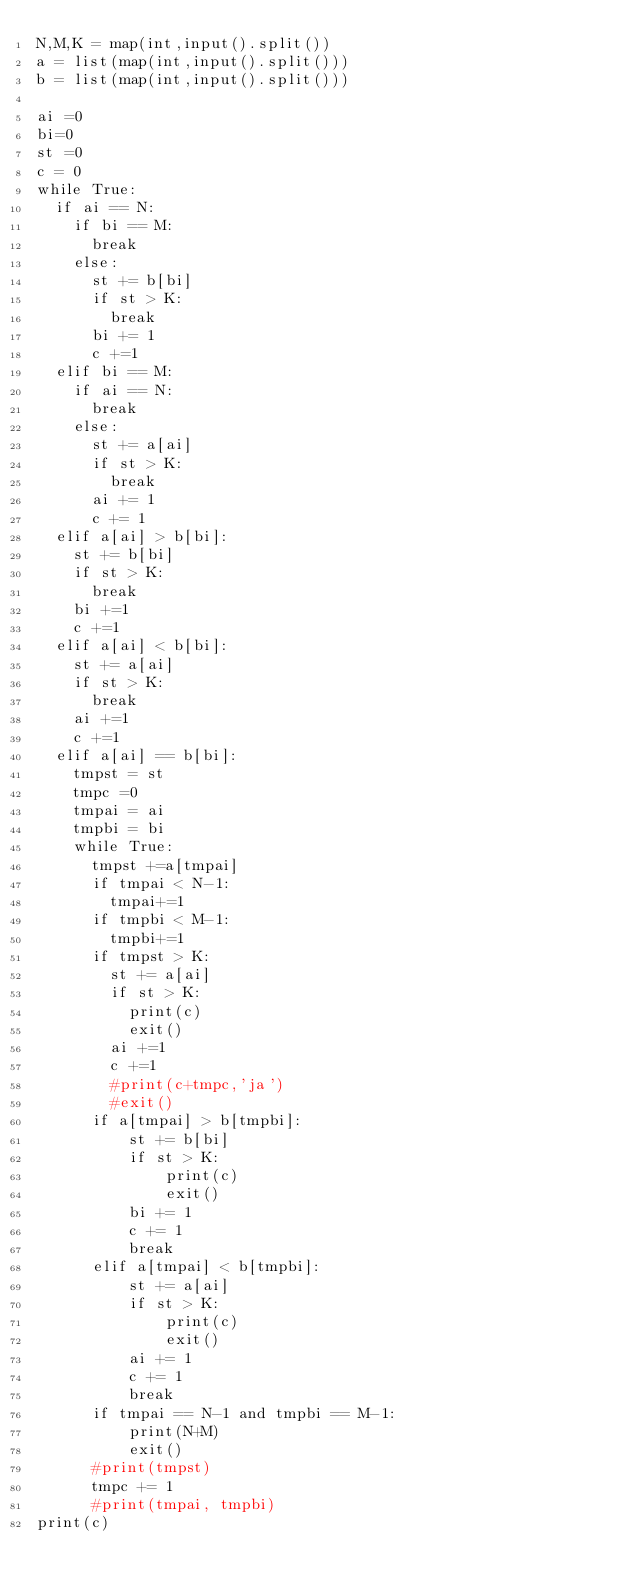Convert code to text. <code><loc_0><loc_0><loc_500><loc_500><_Python_>N,M,K = map(int,input().split())
a = list(map(int,input().split()))
b = list(map(int,input().split()))

ai =0
bi=0
st =0
c = 0
while True:
  if ai == N:
    if bi == M:
      break
    else:
      st += b[bi]
      if st > K:
        break
      bi += 1
      c +=1
  elif bi == M:
    if ai == N:
      break
    else:
      st += a[ai]
      if st > K:
        break
      ai += 1
      c += 1
  elif a[ai] > b[bi]:
    st += b[bi]
    if st > K:
      break
    bi +=1
    c +=1
  elif a[ai] < b[bi]:
    st += a[ai]
    if st > K:
      break
    ai +=1
    c +=1
  elif a[ai] == b[bi]:
    tmpst = st
    tmpc =0
    tmpai = ai
    tmpbi = bi
    while True:
      tmpst +=a[tmpai]
      if tmpai < N-1:
        tmpai+=1
      if tmpbi < M-1:
        tmpbi+=1
      if tmpst > K:
        st += a[ai]
        if st > K:
          print(c)
          exit()
        ai +=1
        c +=1
        #print(c+tmpc,'ja')
        #exit()
      if a[tmpai] > b[tmpbi]:
          st += b[bi]
          if st > K:
              print(c)
              exit()
          bi += 1
          c += 1
          break
      elif a[tmpai] < b[tmpbi]:
          st += a[ai]
          if st > K:
              print(c)
              exit()
          ai += 1
          c += 1
          break
      if tmpai == N-1 and tmpbi == M-1:
          print(N+M)
          exit()
      #print(tmpst)
      tmpc += 1
      #print(tmpai, tmpbi)
print(c)
</code> 